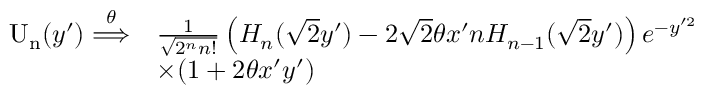Convert formula to latex. <formula><loc_0><loc_0><loc_500><loc_500>\begin{array} { r l } { U _ { n } ( y ^ { \prime } ) \overset { \theta } { \Longrightarrow } } & { \frac { 1 } { \sqrt { 2 ^ { n } n ! } } \left ( H _ { n } ( \sqrt { 2 } y ^ { \prime } ) - 2 \sqrt { 2 } \theta x ^ { \prime } n H _ { n - 1 } ( \sqrt { 2 } y ^ { \prime } ) \right ) e ^ { - y ^ { \prime 2 } } } \\ & { \times ( 1 + 2 \theta x ^ { \prime } y ^ { \prime } ) } \end{array}</formula> 